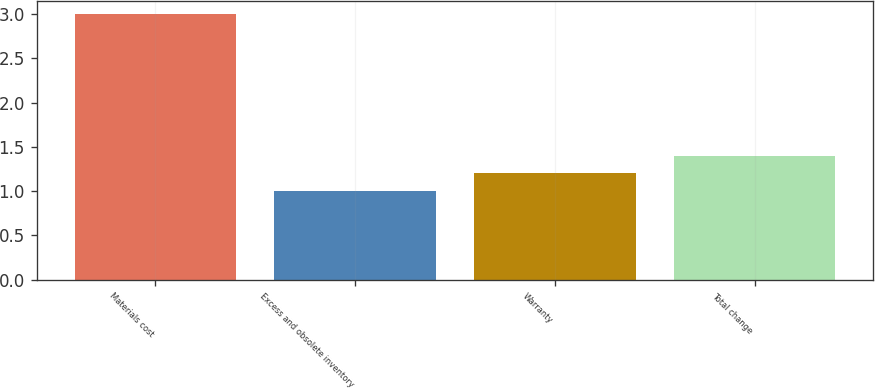<chart> <loc_0><loc_0><loc_500><loc_500><bar_chart><fcel>Materials cost<fcel>Excess and obsolete inventory<fcel>Warranty<fcel>Total change<nl><fcel>3<fcel>1<fcel>1.2<fcel>1.4<nl></chart> 